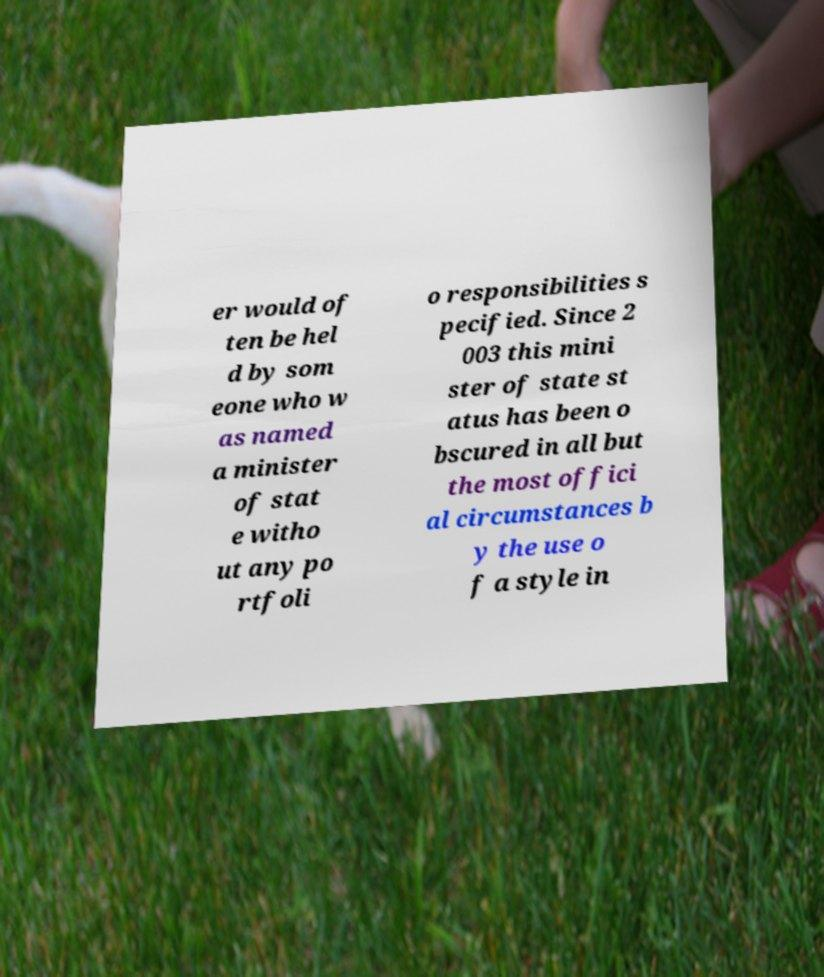Please read and relay the text visible in this image. What does it say? er would of ten be hel d by som eone who w as named a minister of stat e witho ut any po rtfoli o responsibilities s pecified. Since 2 003 this mini ster of state st atus has been o bscured in all but the most offici al circumstances b y the use o f a style in 